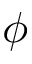<formula> <loc_0><loc_0><loc_500><loc_500>\phi</formula> 